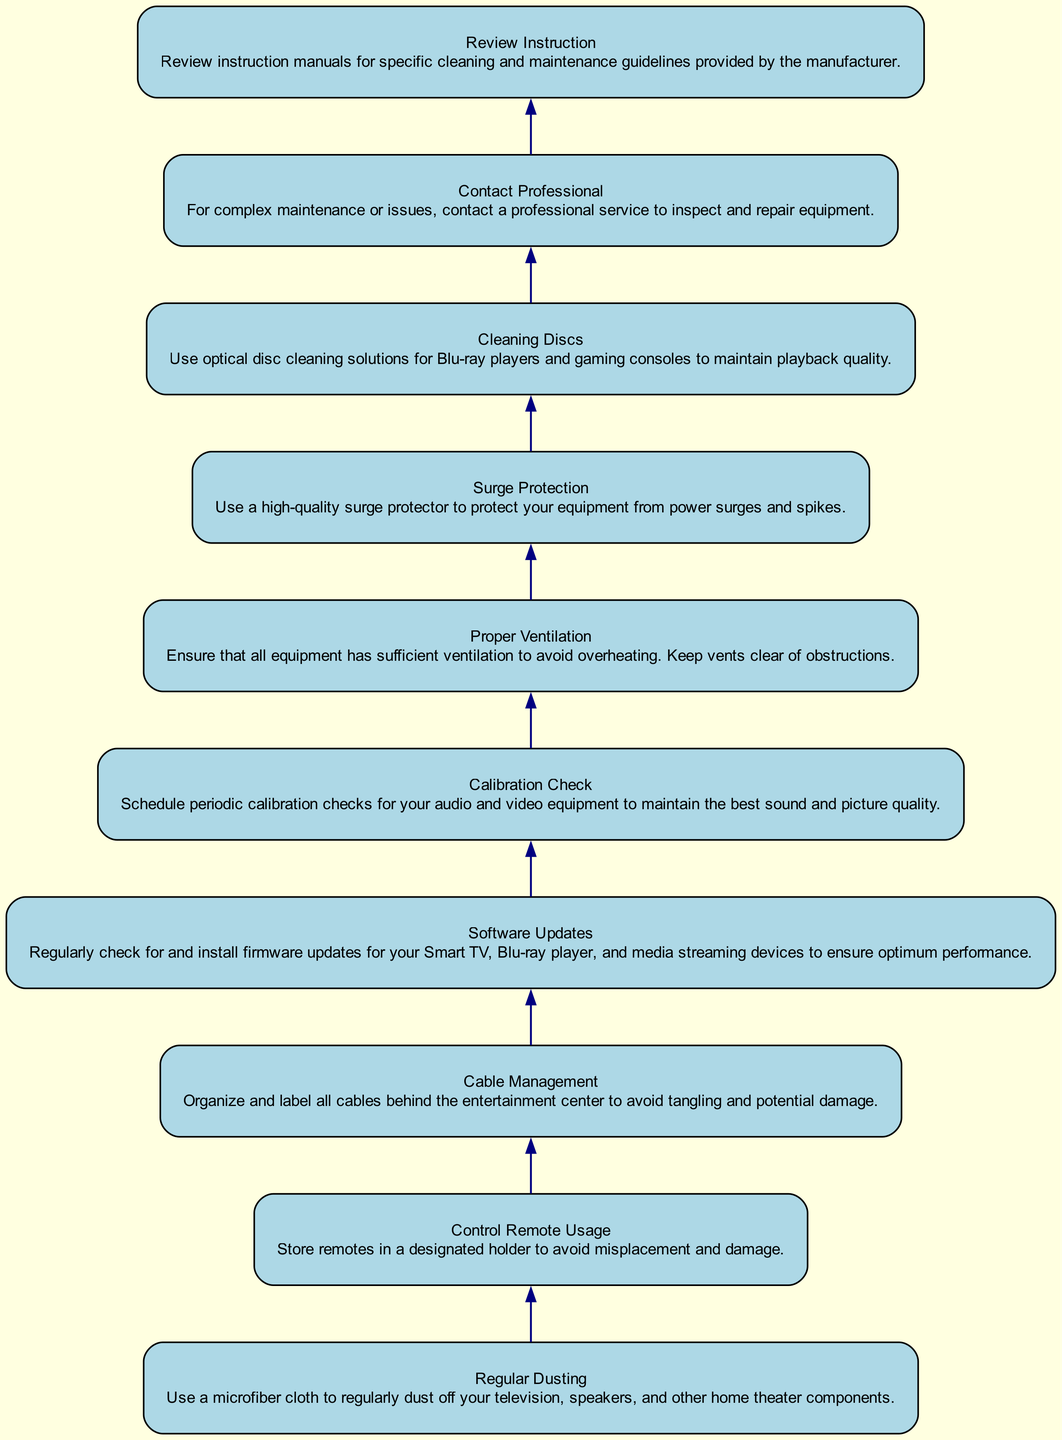What is the topmost node in the flow chart? The flow chart is structured from bottom to top. The topmost node represents the final step in maintaining home theater equipment, which is "Review Instruction".
Answer: Review Instruction How many elements are there in the diagram? By counting all unique nodes in the flow chart, there are 10 distinct elements representing different maintenance tasks.
Answer: 10 What is the function of "Surge Protection"? "Surge Protection" protects home theater equipment from damage due to power surges and spikes. This information can be found directly in the description of the corresponding node.
Answer: Use a high-quality surge protector Which action follows "Calibration Check"? Looking at the order in the flow chart, "Calibration Check" is followed by "Proper Ventilation", which suggests maintaining cooling after checking audio and video quality.
Answer: Proper Ventilation Which task is recommended for cleaning discs? The corresponding node describes that the recommended task for cleaning discs is to use optical disc cleaning solutions for Blu-ray players and gaming consoles.
Answer: Use optical disc cleaning solutions How does "Cable Management" help in equipment maintenance? "Cable Management" prevents tangling and potential damage by organizing and labeling all cables behind the entertainment center. This is derived from the description of that specific node.
Answer: Avoid tangling and potential damage What should you do if you face complex maintenance issues? The corresponding node clearly states that for complex maintenance or issues, the best course of action is to contact a professional service to inspect and repair equipment.
Answer: Contact a professional service Which two nodes directly precede "Software Updates"? To determine the two nodes directly before "Software Updates", we can trace back through the flow chart. They are "Cable Management" and "Control Remote Usage", indicating that managing both cables and remotes is important before ensuring software is up to date.
Answer: Cable Management, Control Remote Usage Which tasks are centered around maintaining adequate airflow for devices? By reviewing the descriptions in the flow chart, "Proper Ventilation" is the primary task dedicated to maintaining airflow, indicating the need to avoid overheating.
Answer: Proper Ventilation 